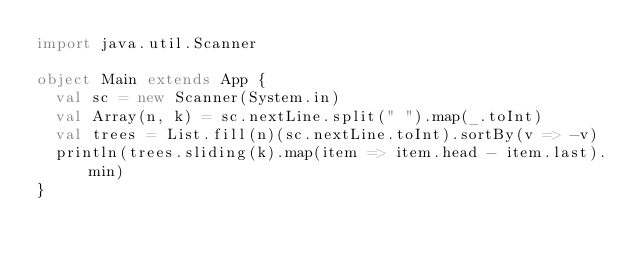Convert code to text. <code><loc_0><loc_0><loc_500><loc_500><_Scala_>import java.util.Scanner

object Main extends App {
  val sc = new Scanner(System.in)
  val Array(n, k) = sc.nextLine.split(" ").map(_.toInt)
  val trees = List.fill(n)(sc.nextLine.toInt).sortBy(v => -v)
  println(trees.sliding(k).map(item => item.head - item.last).min)
}
</code> 